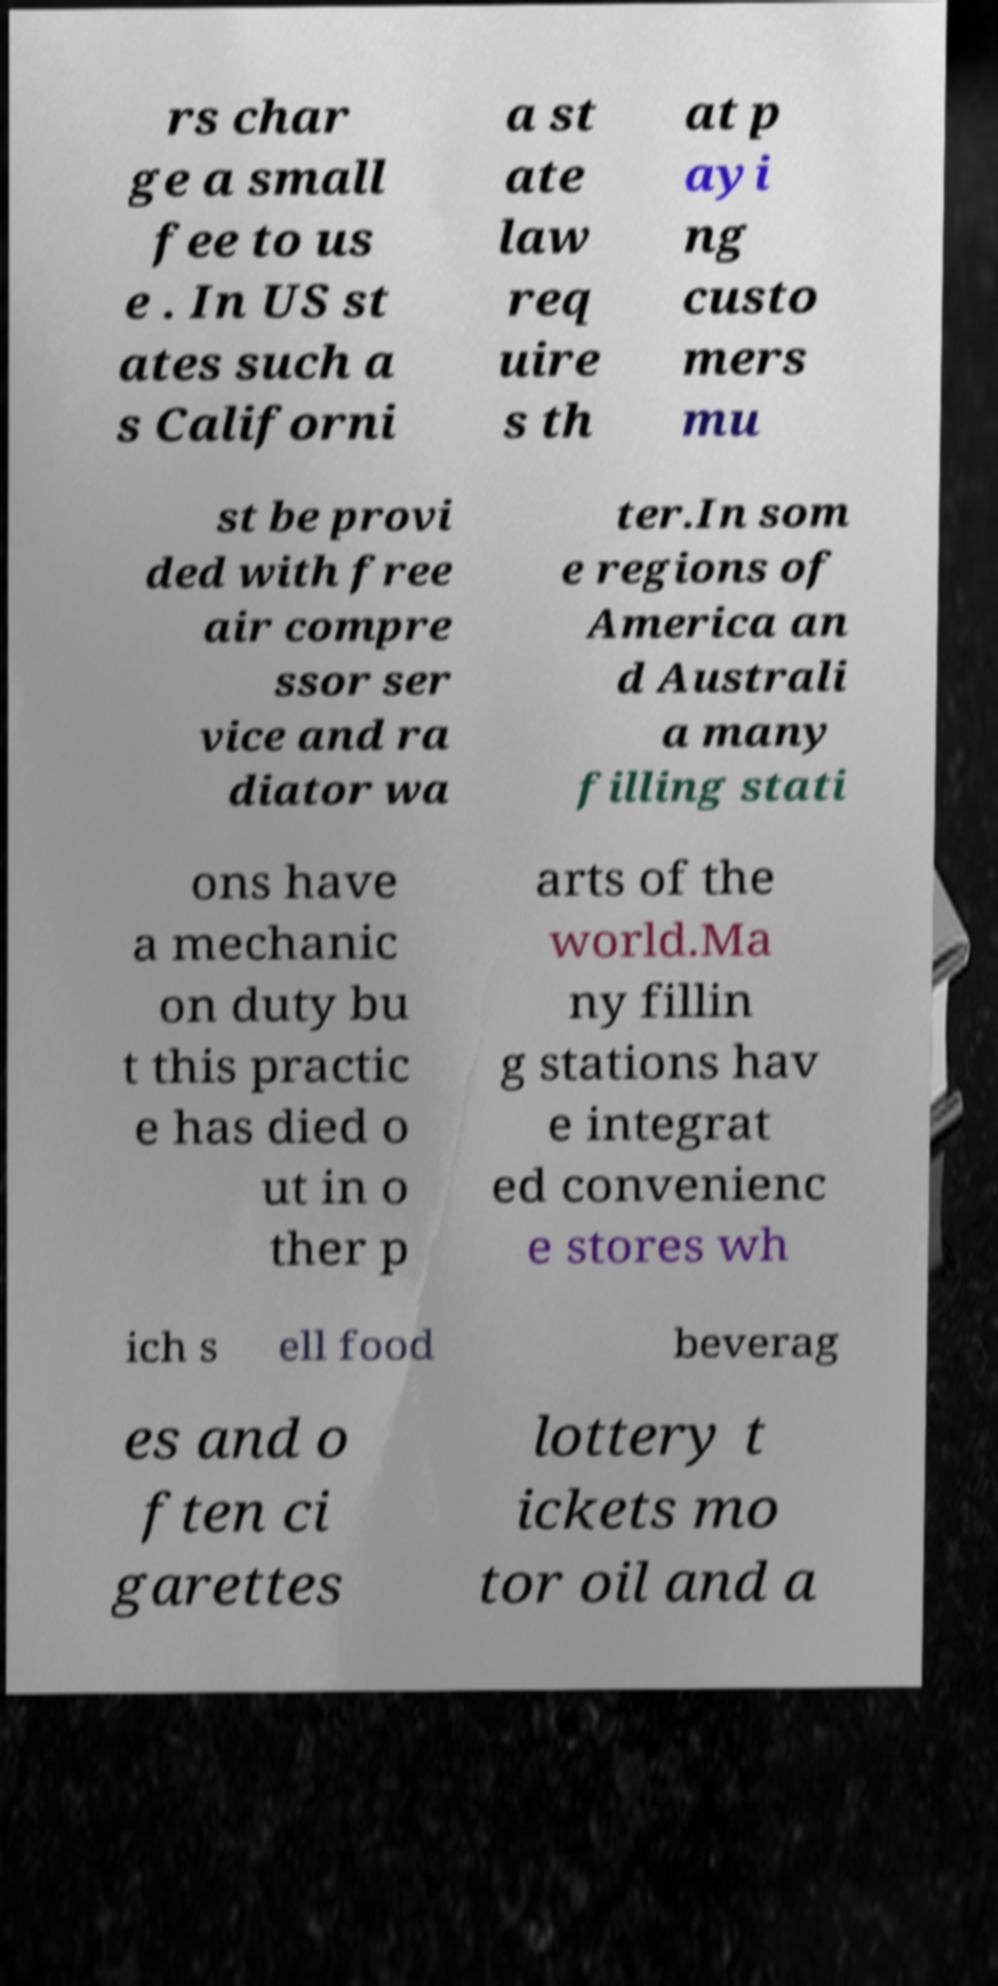Could you assist in decoding the text presented in this image and type it out clearly? rs char ge a small fee to us e . In US st ates such a s Californi a st ate law req uire s th at p ayi ng custo mers mu st be provi ded with free air compre ssor ser vice and ra diator wa ter.In som e regions of America an d Australi a many filling stati ons have a mechanic on duty bu t this practic e has died o ut in o ther p arts of the world.Ma ny fillin g stations hav e integrat ed convenienc e stores wh ich s ell food beverag es and o ften ci garettes lottery t ickets mo tor oil and a 